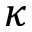Convert formula to latex. <formula><loc_0><loc_0><loc_500><loc_500>\kappa</formula> 